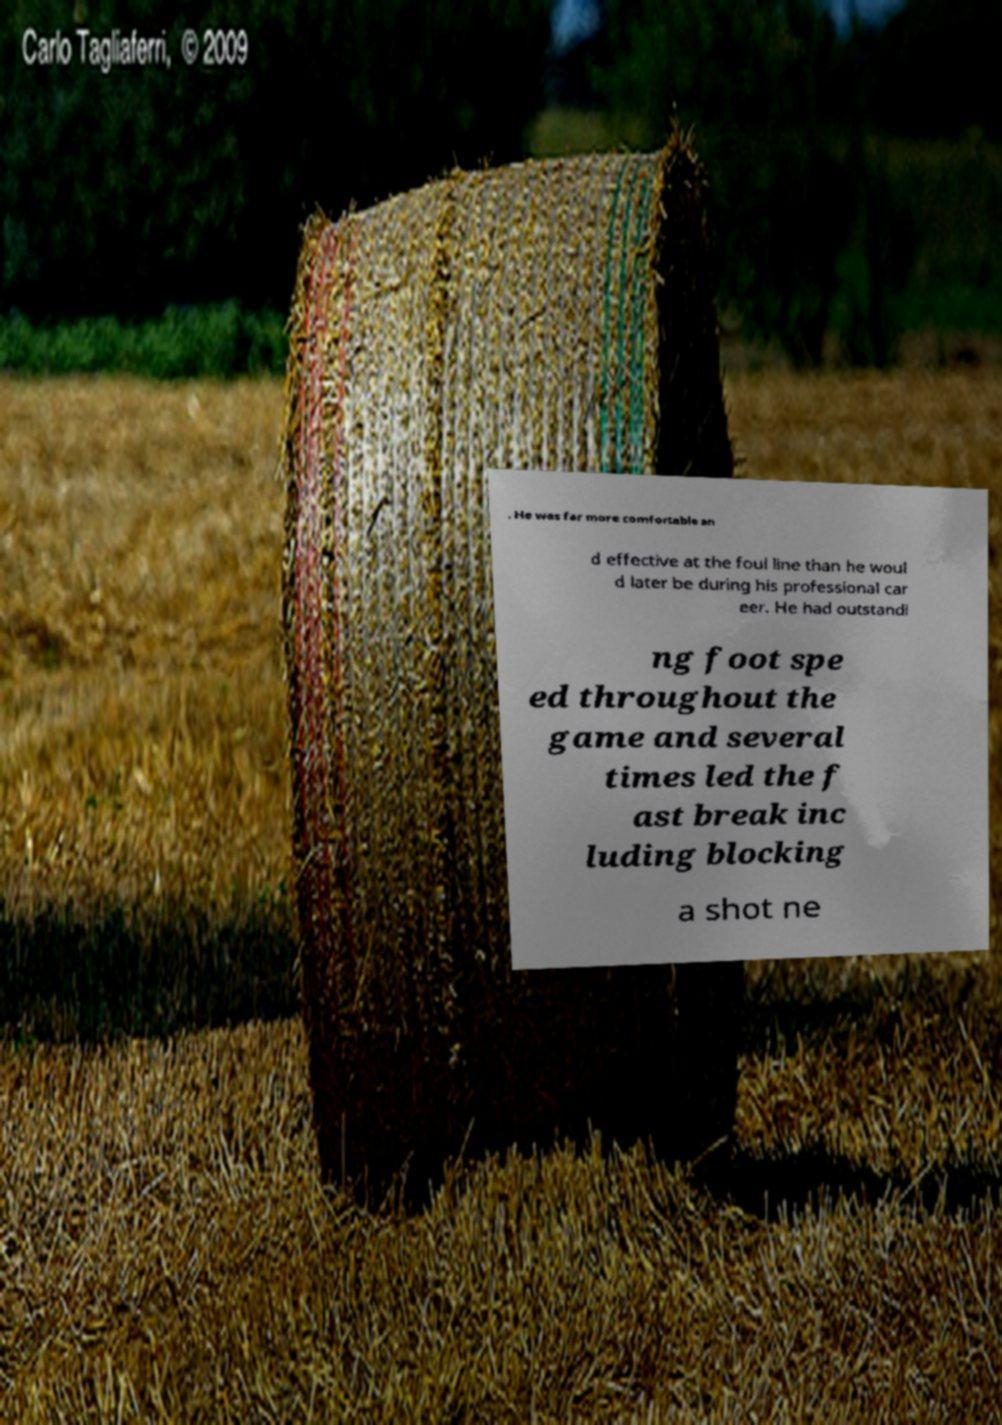For documentation purposes, I need the text within this image transcribed. Could you provide that? . He was far more comfortable an d effective at the foul line than he woul d later be during his professional car eer. He had outstandi ng foot spe ed throughout the game and several times led the f ast break inc luding blocking a shot ne 